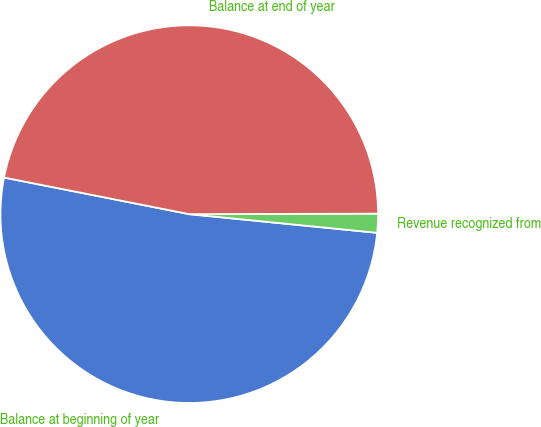Convert chart to OTSL. <chart><loc_0><loc_0><loc_500><loc_500><pie_chart><fcel>Balance at beginning of year<fcel>Revenue recognized from<fcel>Balance at end of year<nl><fcel>51.53%<fcel>1.62%<fcel>46.85%<nl></chart> 